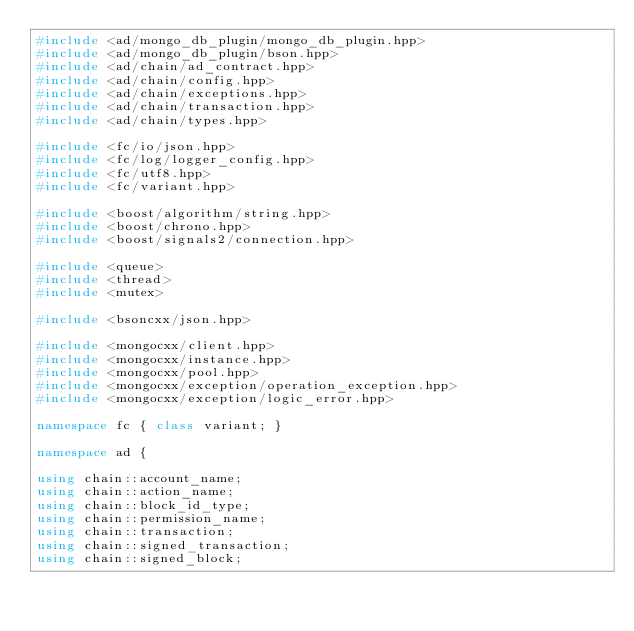Convert code to text. <code><loc_0><loc_0><loc_500><loc_500><_C++_>#include <ad/mongo_db_plugin/mongo_db_plugin.hpp>
#include <ad/mongo_db_plugin/bson.hpp>
#include <ad/chain/ad_contract.hpp>
#include <ad/chain/config.hpp>
#include <ad/chain/exceptions.hpp>
#include <ad/chain/transaction.hpp>
#include <ad/chain/types.hpp>

#include <fc/io/json.hpp>
#include <fc/log/logger_config.hpp>
#include <fc/utf8.hpp>
#include <fc/variant.hpp>

#include <boost/algorithm/string.hpp>
#include <boost/chrono.hpp>
#include <boost/signals2/connection.hpp>

#include <queue>
#include <thread>
#include <mutex>

#include <bsoncxx/json.hpp>

#include <mongocxx/client.hpp>
#include <mongocxx/instance.hpp>
#include <mongocxx/pool.hpp>
#include <mongocxx/exception/operation_exception.hpp>
#include <mongocxx/exception/logic_error.hpp>

namespace fc { class variant; }

namespace ad {

using chain::account_name;
using chain::action_name;
using chain::block_id_type;
using chain::permission_name;
using chain::transaction;
using chain::signed_transaction;
using chain::signed_block;</code> 